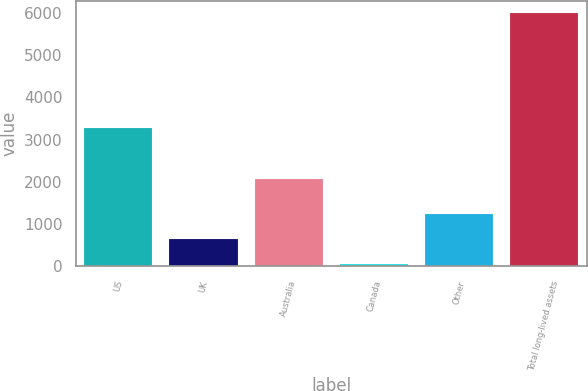Convert chart. <chart><loc_0><loc_0><loc_500><loc_500><bar_chart><fcel>US<fcel>UK<fcel>Australia<fcel>Canada<fcel>Other<fcel>Total long-lived assets<nl><fcel>3282.5<fcel>646.27<fcel>2061.7<fcel>52.4<fcel>1240.14<fcel>5991.1<nl></chart> 